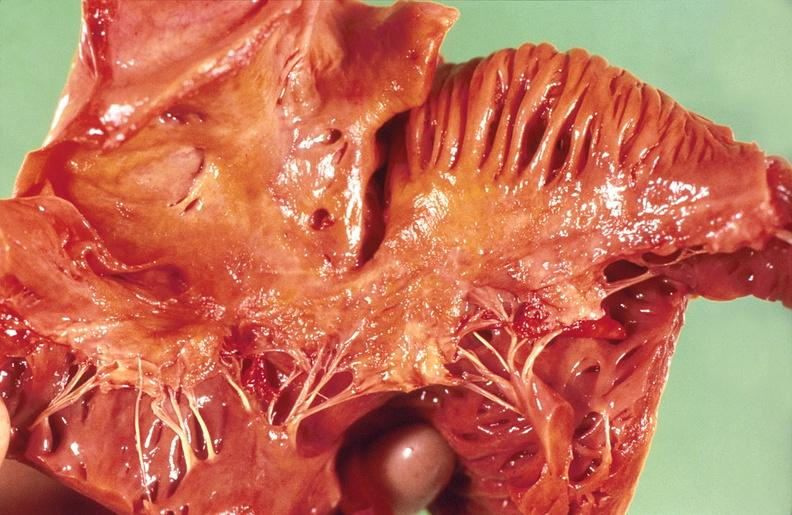s chest and abdomen slide present?
Answer the question using a single word or phrase. No 